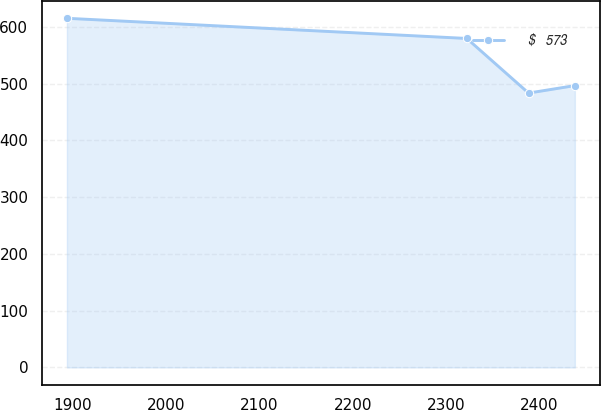<chart> <loc_0><loc_0><loc_500><loc_500><line_chart><ecel><fcel>$   573<nl><fcel>1893.5<fcel>615.06<nl><fcel>2322.26<fcel>579.53<nl><fcel>2388.45<fcel>483.33<nl><fcel>2438.07<fcel>496.5<nl></chart> 